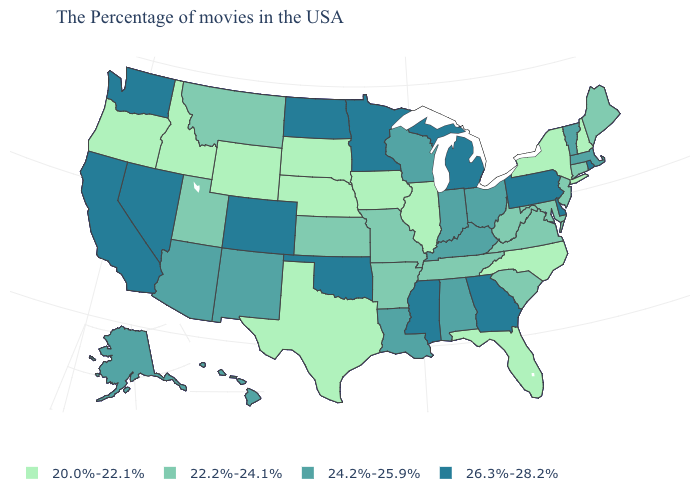Which states have the highest value in the USA?
Answer briefly. Rhode Island, Delaware, Pennsylvania, Georgia, Michigan, Mississippi, Minnesota, Oklahoma, North Dakota, Colorado, Nevada, California, Washington. What is the lowest value in the MidWest?
Answer briefly. 20.0%-22.1%. Name the states that have a value in the range 26.3%-28.2%?
Be succinct. Rhode Island, Delaware, Pennsylvania, Georgia, Michigan, Mississippi, Minnesota, Oklahoma, North Dakota, Colorado, Nevada, California, Washington. What is the value of Colorado?
Be succinct. 26.3%-28.2%. What is the value of Montana?
Give a very brief answer. 22.2%-24.1%. What is the value of Arizona?
Give a very brief answer. 24.2%-25.9%. Which states hav the highest value in the West?
Give a very brief answer. Colorado, Nevada, California, Washington. Name the states that have a value in the range 24.2%-25.9%?
Be succinct. Massachusetts, Vermont, Ohio, Kentucky, Indiana, Alabama, Wisconsin, Louisiana, New Mexico, Arizona, Alaska, Hawaii. Does North Dakota have a lower value than South Carolina?
Concise answer only. No. Name the states that have a value in the range 22.2%-24.1%?
Give a very brief answer. Maine, Connecticut, New Jersey, Maryland, Virginia, South Carolina, West Virginia, Tennessee, Missouri, Arkansas, Kansas, Utah, Montana. Name the states that have a value in the range 20.0%-22.1%?
Keep it brief. New Hampshire, New York, North Carolina, Florida, Illinois, Iowa, Nebraska, Texas, South Dakota, Wyoming, Idaho, Oregon. Name the states that have a value in the range 26.3%-28.2%?
Short answer required. Rhode Island, Delaware, Pennsylvania, Georgia, Michigan, Mississippi, Minnesota, Oklahoma, North Dakota, Colorado, Nevada, California, Washington. What is the highest value in states that border Michigan?
Answer briefly. 24.2%-25.9%. Does Missouri have the same value as Rhode Island?
Be succinct. No. What is the highest value in the MidWest ?
Give a very brief answer. 26.3%-28.2%. 